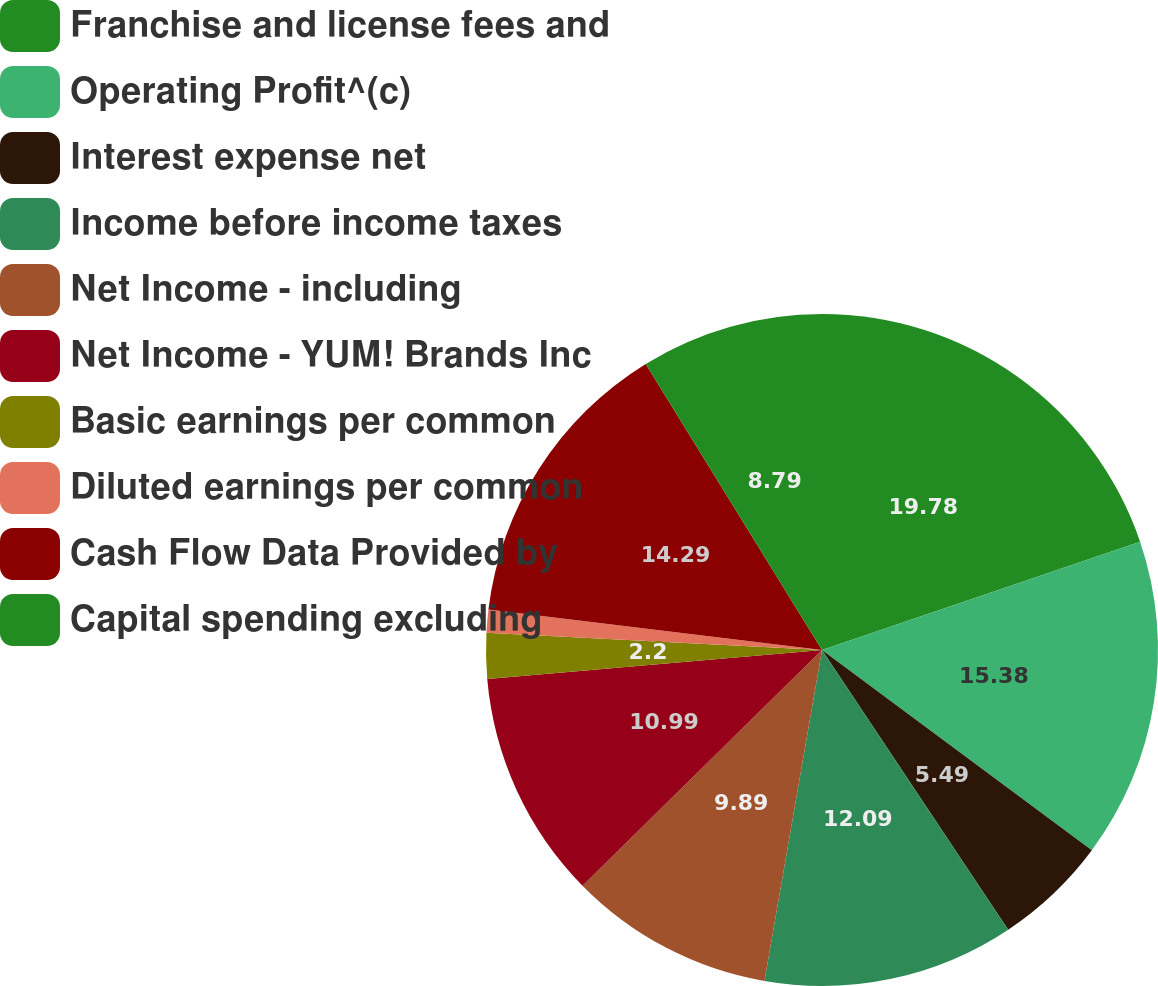<chart> <loc_0><loc_0><loc_500><loc_500><pie_chart><fcel>Franchise and license fees and<fcel>Operating Profit^(c)<fcel>Interest expense net<fcel>Income before income taxes<fcel>Net Income - including<fcel>Net Income - YUM! Brands Inc<fcel>Basic earnings per common<fcel>Diluted earnings per common<fcel>Cash Flow Data Provided by<fcel>Capital spending excluding<nl><fcel>19.78%<fcel>15.38%<fcel>5.49%<fcel>12.09%<fcel>9.89%<fcel>10.99%<fcel>2.2%<fcel>1.1%<fcel>14.29%<fcel>8.79%<nl></chart> 